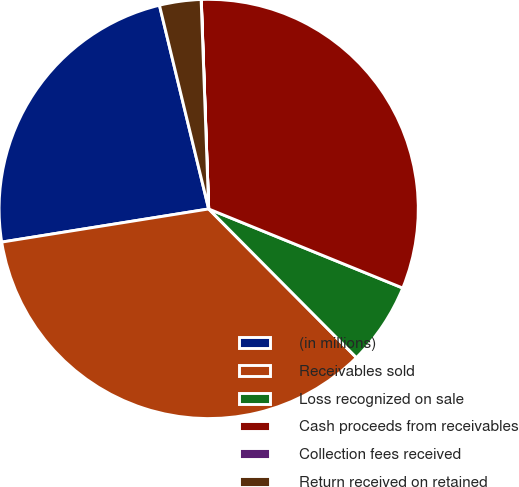<chart> <loc_0><loc_0><loc_500><loc_500><pie_chart><fcel>(in millions)<fcel>Receivables sold<fcel>Loss recognized on sale<fcel>Cash proceeds from receivables<fcel>Collection fees received<fcel>Return received on retained<nl><fcel>23.75%<fcel>34.92%<fcel>6.39%<fcel>31.72%<fcel>0.01%<fcel>3.2%<nl></chart> 